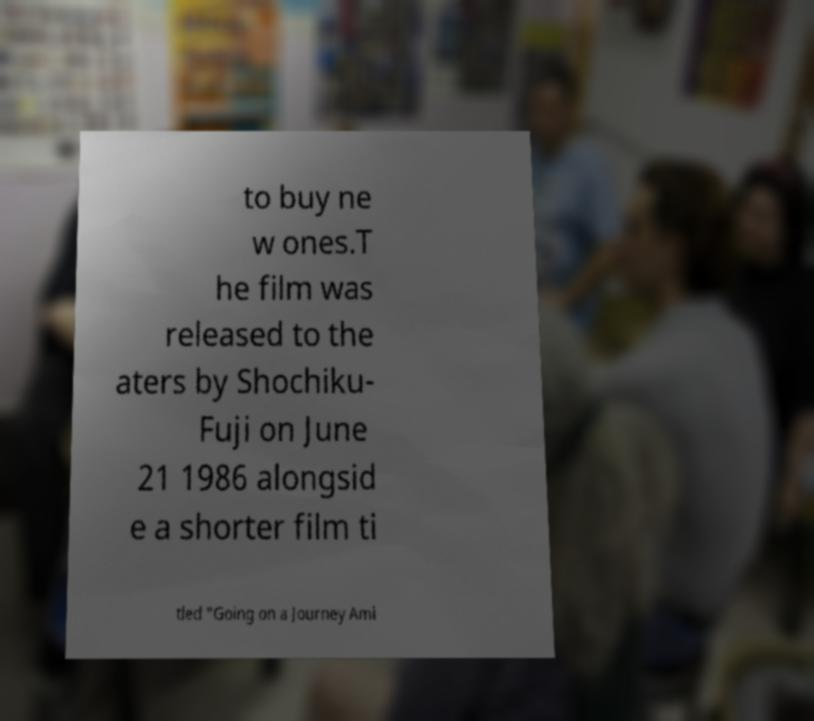I need the written content from this picture converted into text. Can you do that? to buy ne w ones.T he film was released to the aters by Shochiku- Fuji on June 21 1986 alongsid e a shorter film ti tled "Going on a Journey Ami 